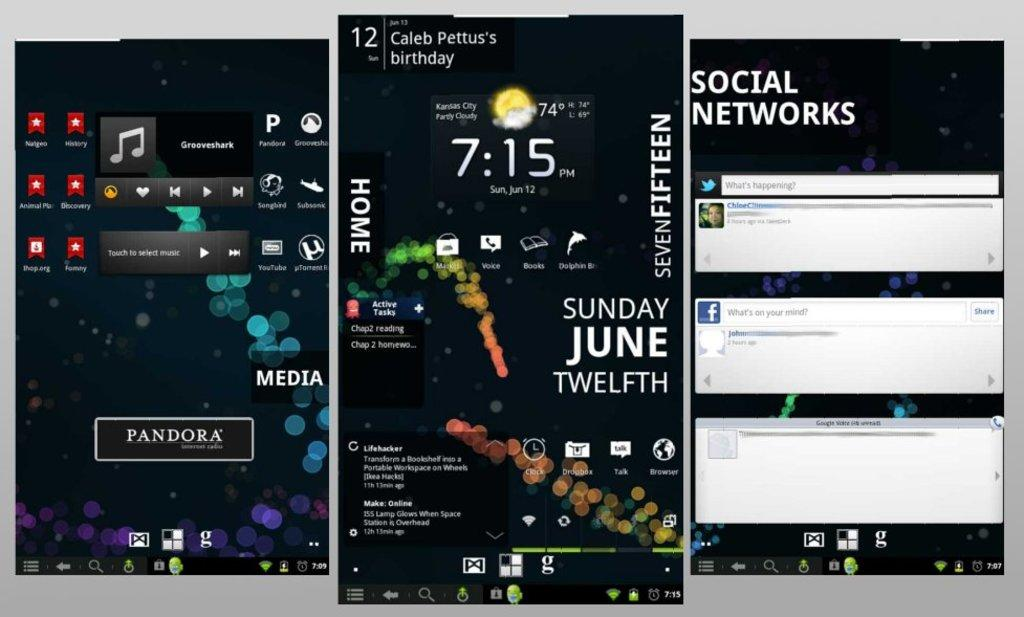<image>
Present a compact description of the photo's key features. a phone with the time of 7:15 on it 